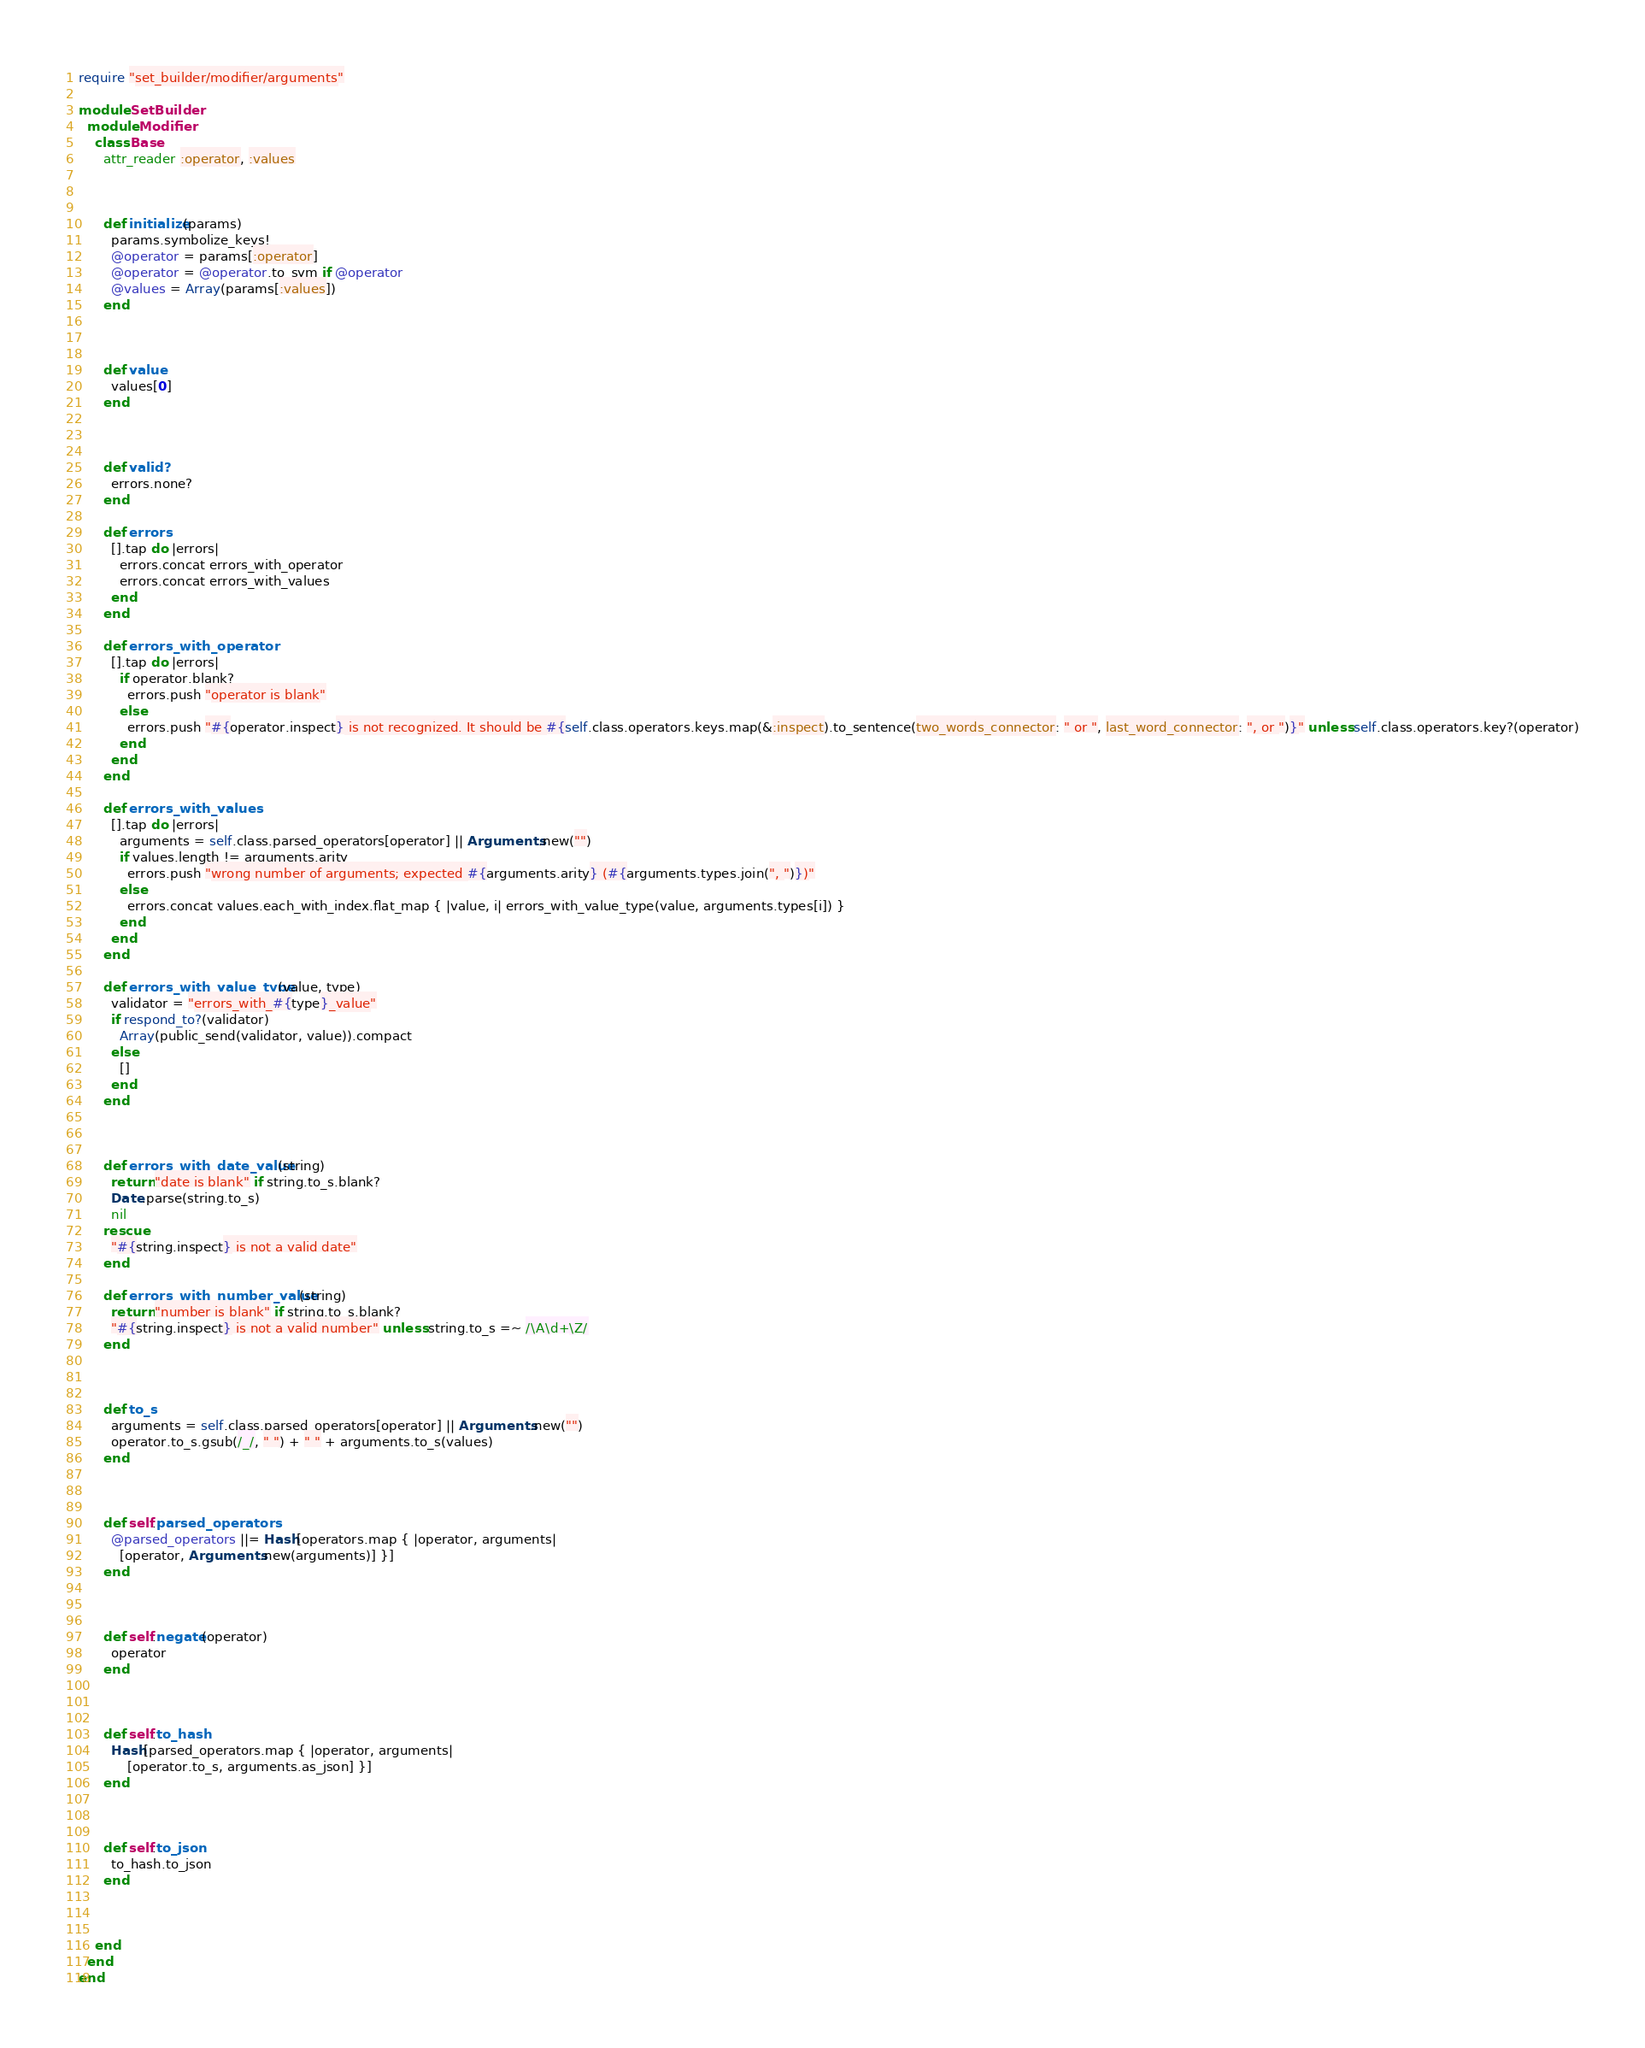Convert code to text. <code><loc_0><loc_0><loc_500><loc_500><_Ruby_>require "set_builder/modifier/arguments"

module SetBuilder
  module Modifier
    class Base
      attr_reader :operator, :values



      def initialize(params)
        params.symbolize_keys!
        @operator = params[:operator]
        @operator = @operator.to_sym if @operator
        @values = Array(params[:values])
      end



      def value
        values[0]
      end



      def valid?
        errors.none?
      end

      def errors
        [].tap do |errors|
          errors.concat errors_with_operator
          errors.concat errors_with_values
        end
      end

      def errors_with_operator
        [].tap do |errors|
          if operator.blank?
            errors.push "operator is blank"
          else
            errors.push "#{operator.inspect} is not recognized. It should be #{self.class.operators.keys.map(&:inspect).to_sentence(two_words_connector: " or ", last_word_connector: ", or ")}" unless self.class.operators.key?(operator)
          end
        end
      end

      def errors_with_values
        [].tap do |errors|
          arguments = self.class.parsed_operators[operator] || Arguments.new("")
          if values.length != arguments.arity
            errors.push "wrong number of arguments; expected #{arguments.arity} (#{arguments.types.join(", ")})"
          else
            errors.concat values.each_with_index.flat_map { |value, i| errors_with_value_type(value, arguments.types[i]) }
          end
        end
      end

      def errors_with_value_type(value, type)
        validator = "errors_with_#{type}_value"
        if respond_to?(validator)
          Array(public_send(validator, value)).compact
        else
          []
        end
      end



      def errors_with_date_value(string)
        return "date is blank" if string.to_s.blank?
        Date.parse(string.to_s)
        nil
      rescue
        "#{string.inspect} is not a valid date"
      end

      def errors_with_number_value(string)
        return "number is blank" if string.to_s.blank?
        "#{string.inspect} is not a valid number" unless string.to_s =~ /\A\d+\Z/
      end



      def to_s
        arguments = self.class.parsed_operators[operator] || Arguments.new("")
        operator.to_s.gsub(/_/, " ") + " " + arguments.to_s(values)
      end



      def self.parsed_operators
        @parsed_operators ||= Hash[operators.map { |operator, arguments|
          [operator, Arguments.new(arguments)] }]
      end



      def self.negate(operator)
        operator
      end



      def self.to_hash
        Hash[parsed_operators.map { |operator, arguments|
            [operator.to_s, arguments.as_json] }]
      end



      def self.to_json
        to_hash.to_json
      end



    end
  end
end
</code> 